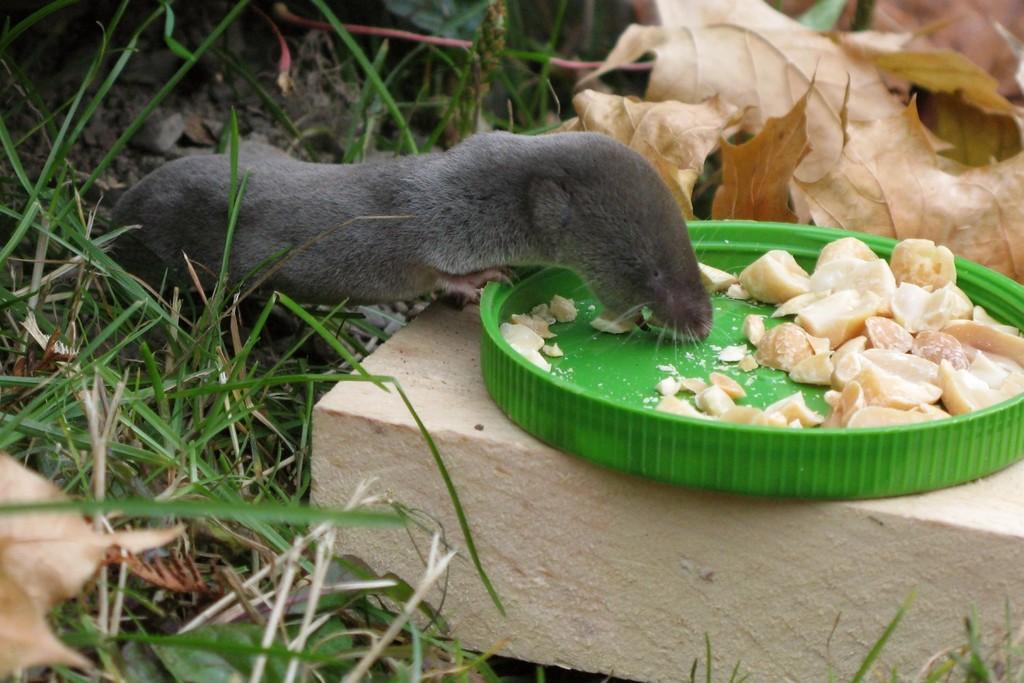Please provide a concise description of this image. In this image I can see a green colour thing on the right side and on it I can see food. On the left side of this image I can see grass and a grey colour animal. I can also see leaves on the top right side of this image. 